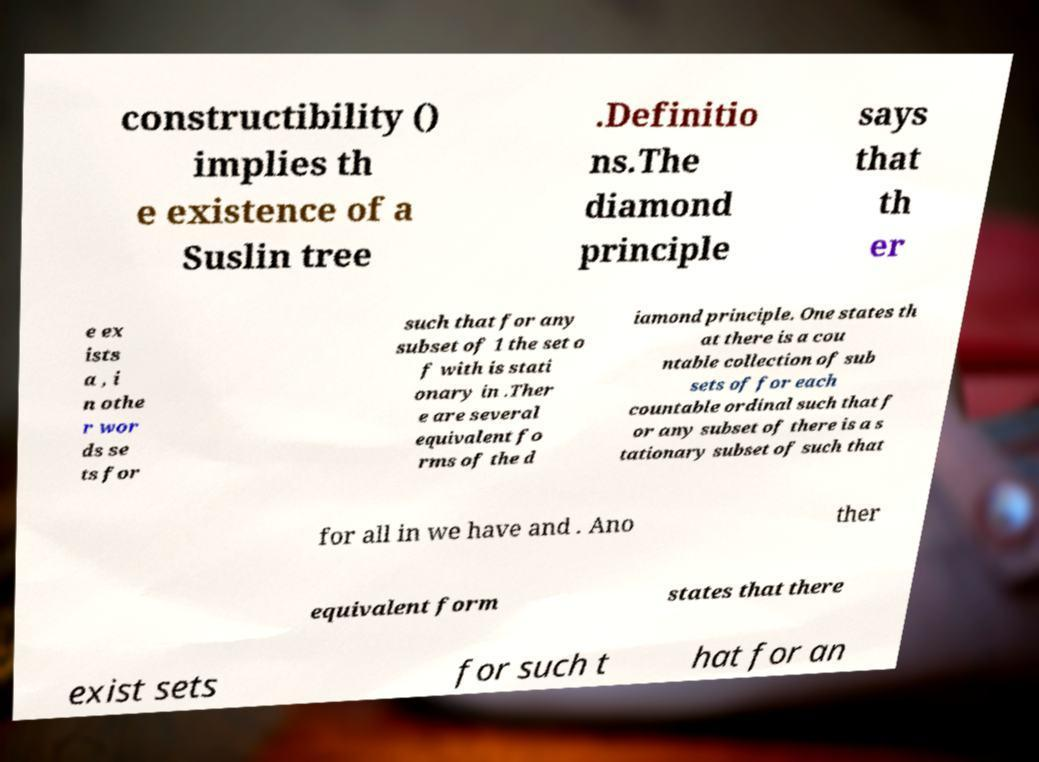Could you extract and type out the text from this image? constructibility () implies th e existence of a Suslin tree .Definitio ns.The diamond principle says that th er e ex ists a , i n othe r wor ds se ts for such that for any subset of 1 the set o f with is stati onary in .Ther e are several equivalent fo rms of the d iamond principle. One states th at there is a cou ntable collection of sub sets of for each countable ordinal such that f or any subset of there is a s tationary subset of such that for all in we have and . Ano ther equivalent form states that there exist sets for such t hat for an 